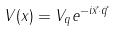Convert formula to latex. <formula><loc_0><loc_0><loc_500><loc_500>V ( x ) = V _ { q } e ^ { - i \vec { x } \cdot \vec { q } }</formula> 